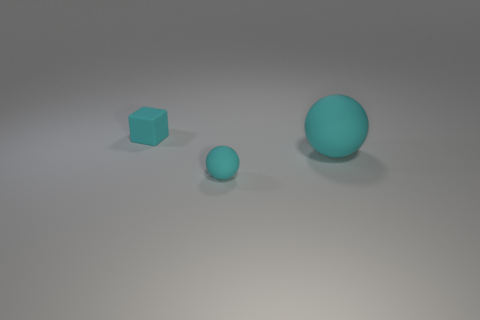Subtract all cubes. How many objects are left? 2 Subtract all tiny objects. Subtract all big red spheres. How many objects are left? 1 Add 2 tiny objects. How many tiny objects are left? 4 Add 2 small gray spheres. How many small gray spheres exist? 2 Add 1 big matte things. How many objects exist? 4 Subtract 1 cyan cubes. How many objects are left? 2 Subtract all red spheres. Subtract all brown blocks. How many spheres are left? 2 